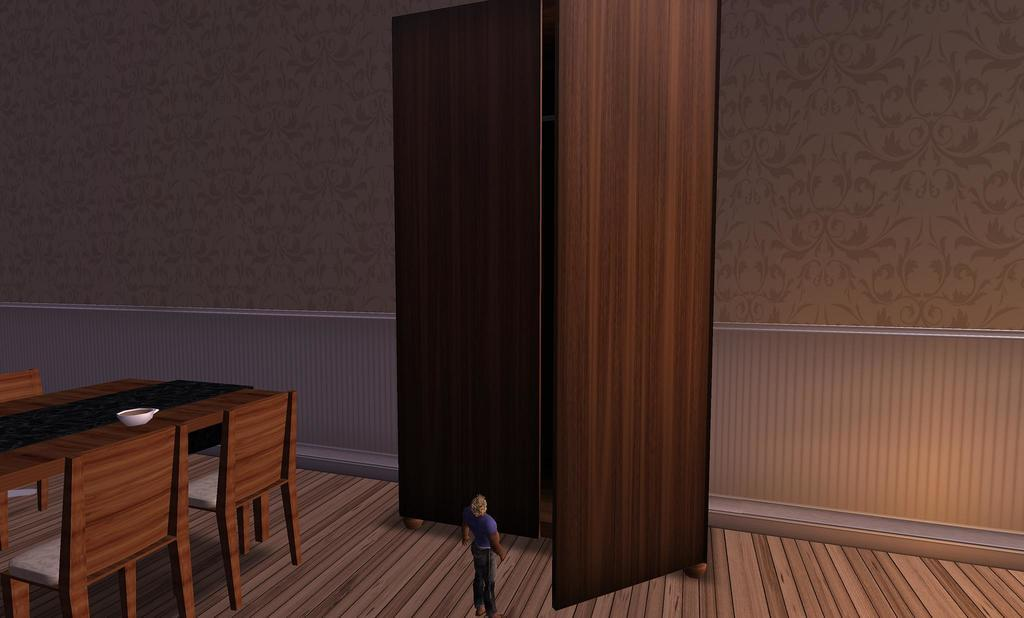What type of picture is the image? The image is an animated picture. What furniture is present in the image? There is a table and chairs in the image. Who or what is in the image? There is a person in the image. What is on the table in the image? There is a bowl on the table. What can be seen in the background of the image? There is a wall and a door in the background of the image. How many flocks of dirt can be seen on the person's shoes in the image? There is no dirt or flocks of dirt visible on the person's shoes in the image. 